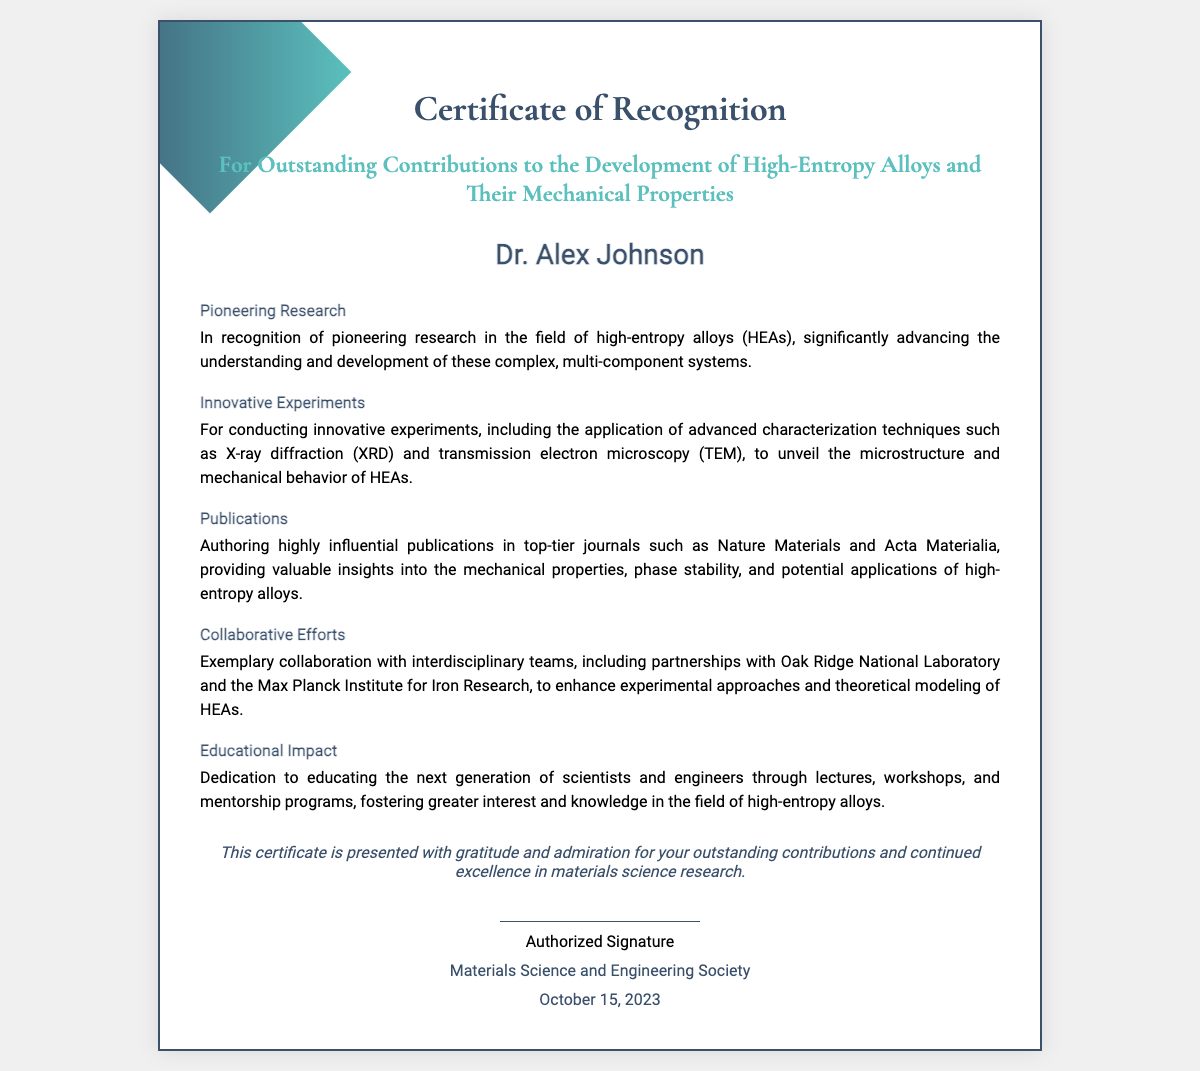What is the name of the recipient? The recipient's name is prominently stated at the center of the certificate.
Answer: Dr. Alex Johnson What is the date of the certificate? The date is located towards the bottom of the certificate, indicating when it was presented.
Answer: October 15, 2023 What organization issued the certificate? The organization issuing the certificate is mentioned at the bottom of the document.
Answer: Materials Science and Engineering Society Which advanced characterization techniques are mentioned? The document lists specific techniques utilized in the research achievements under the "Innovative Experiments" section.
Answer: X-ray diffraction and transmission electron microscopy What is the main focus of the research recognized by the certificate? The focus of the research is outlined in the title and first section, centering on specific contributions and developments.
Answer: High-Entropy Alloys How does the certificate describe the impact on education? The section detailing educational contributions highlights the recipient's efforts to educate future scientists and engineers.
Answer: Mentorship programs In which top-tier journals were publications made? The "Publications" section specifies notable journals where the recipient's work was published.
Answer: Nature Materials and Acta Materialia What type of collaborations are highlighted in the certificate? The document mentions collaborative efforts to enhance experimental approaches and theoretical modeling.
Answer: Interdisciplinary teams 